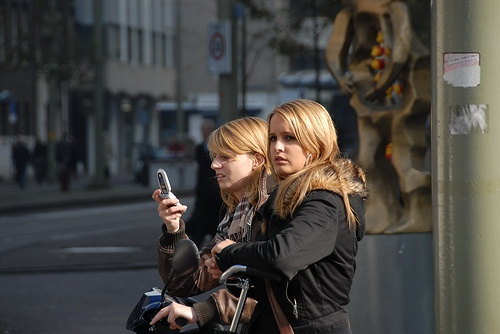Describe the objects in this image and their specific colors. I can see people in black, gray, and maroon tones, people in black, gray, and maroon tones, motorcycle in black, gray, navy, and darkgray tones, handbag in black, maroon, brown, and gray tones, and people in black tones in this image. 